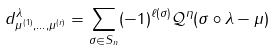Convert formula to latex. <formula><loc_0><loc_0><loc_500><loc_500>d _ { \mu ^ { ( 1 ) } , \dots , \mu ^ { ( r ) } } ^ { \lambda } = \sum _ { \sigma \in S _ { n } } ( - 1 ) ^ { \ell ( \sigma ) } \mathcal { Q } ^ { \eta } ( \sigma \circ \lambda - \mu )</formula> 